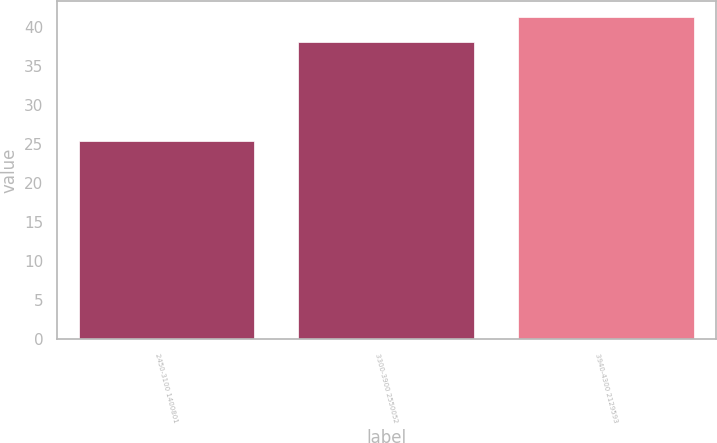Convert chart. <chart><loc_0><loc_0><loc_500><loc_500><bar_chart><fcel>2450-3100 1400801<fcel>3300-3900 2550052<fcel>3940-4300 2129593<nl><fcel>25.32<fcel>38.09<fcel>41.17<nl></chart> 